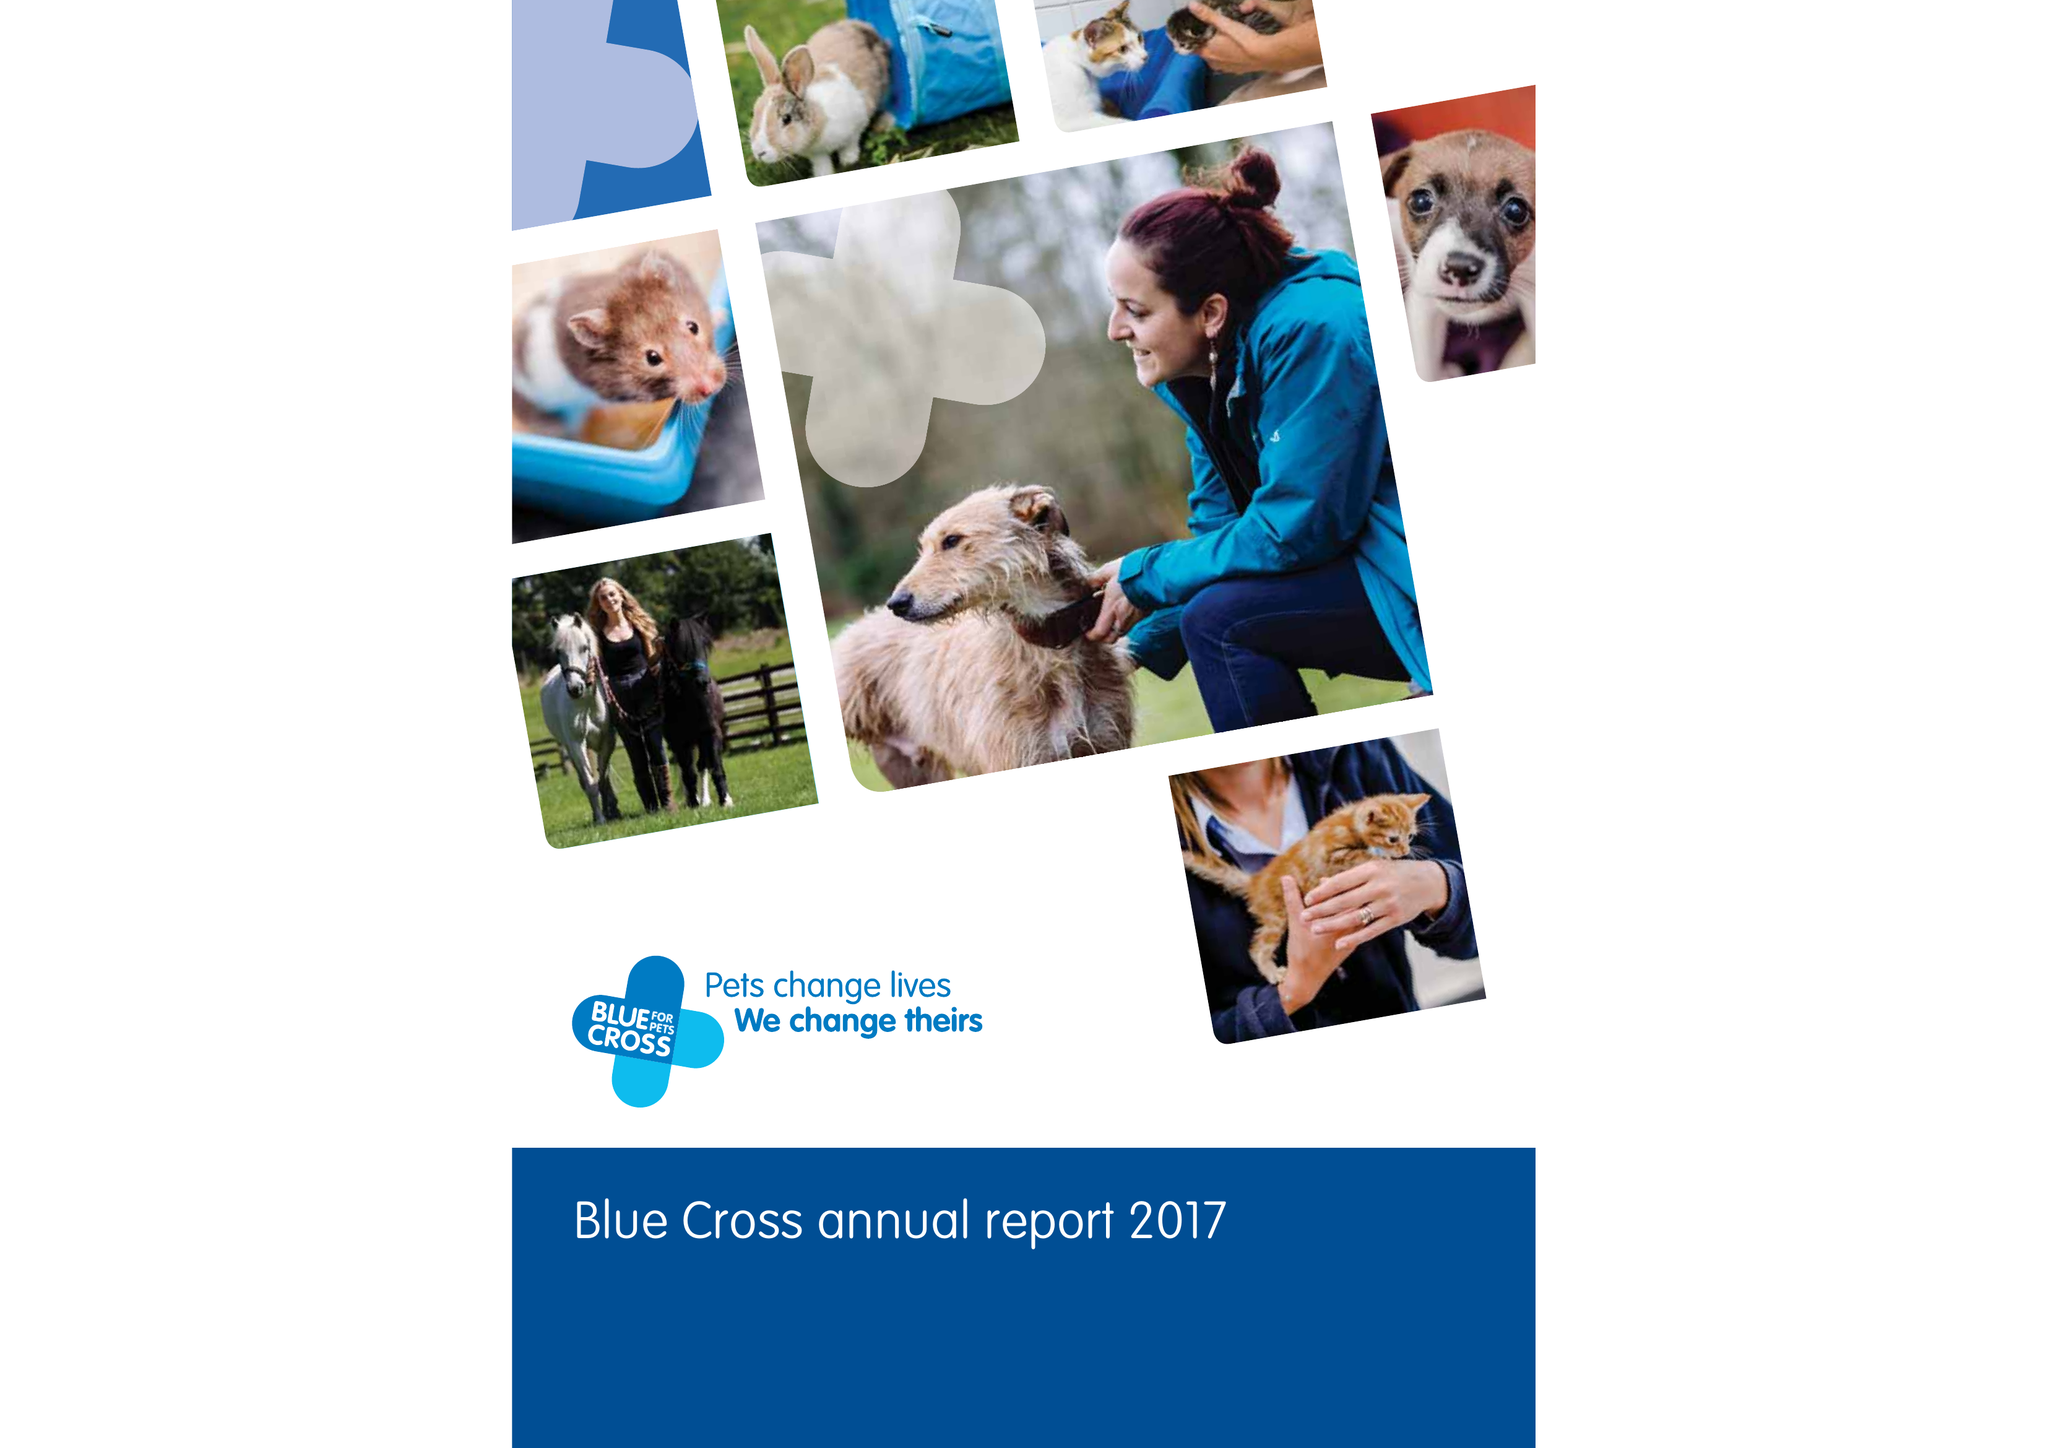What is the value for the address__postcode?
Answer the question using a single word or phrase. OX18 4PF 